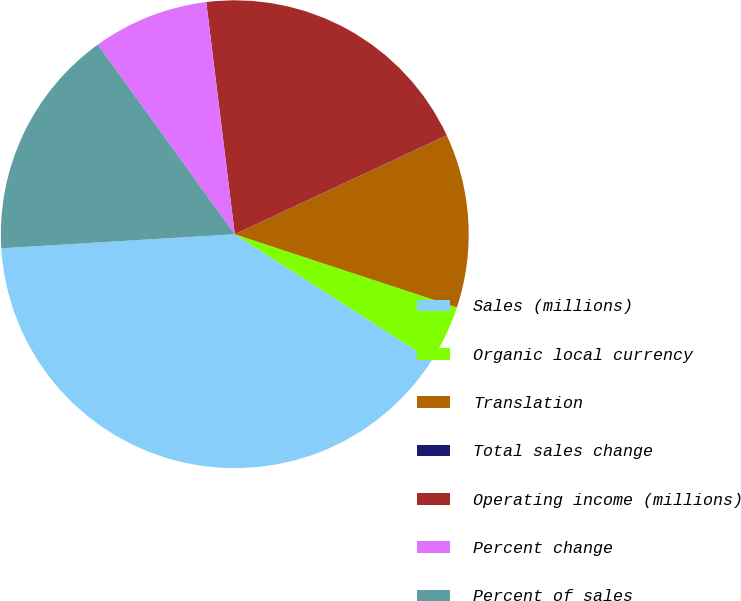<chart> <loc_0><loc_0><loc_500><loc_500><pie_chart><fcel>Sales (millions)<fcel>Organic local currency<fcel>Translation<fcel>Total sales change<fcel>Operating income (millions)<fcel>Percent change<fcel>Percent of sales<nl><fcel>39.96%<fcel>4.01%<fcel>12.0%<fcel>0.02%<fcel>19.99%<fcel>8.01%<fcel>16.0%<nl></chart> 